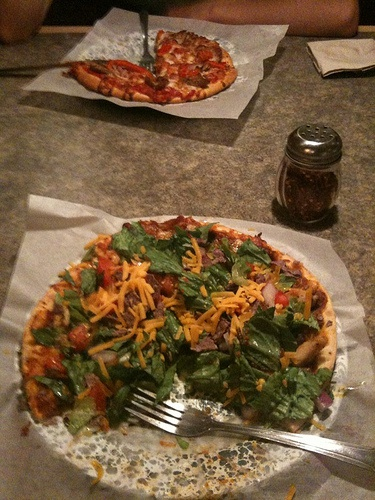Describe the objects in this image and their specific colors. I can see dining table in olive, black, gray, and maroon tones, pizza in maroon, black, olive, and brown tones, pizza in maroon and brown tones, people in maroon, brown, and black tones, and fork in maroon, white, gray, and black tones in this image. 